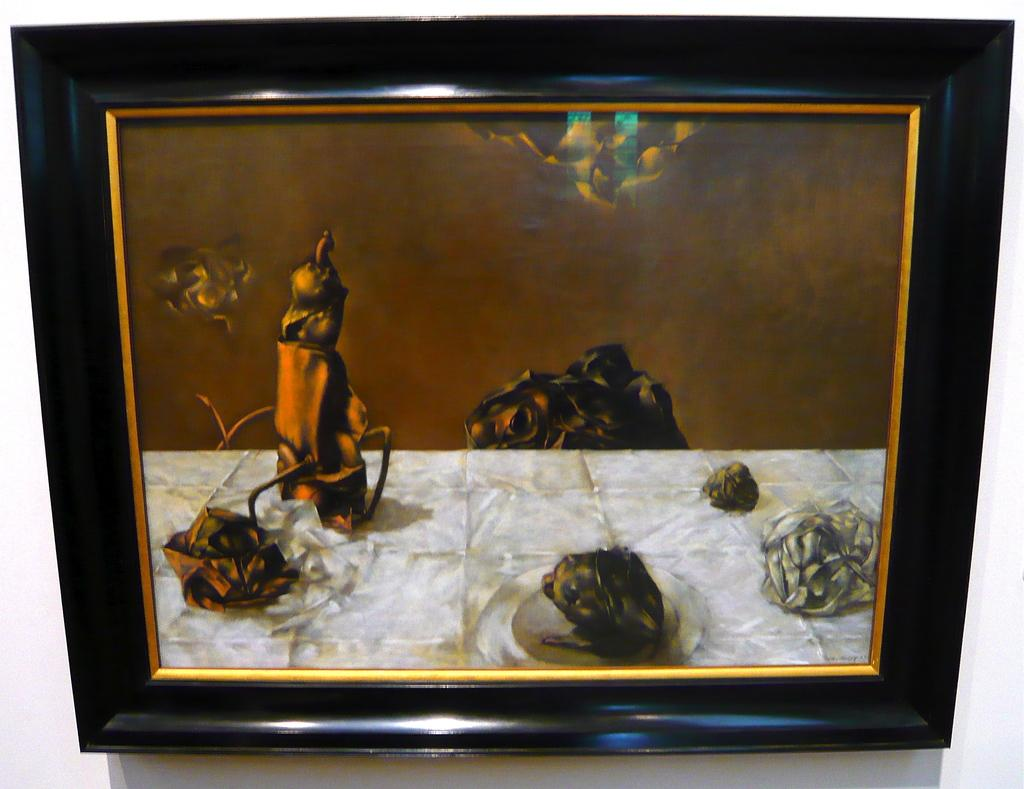What is hanging on the wall in the image? There is a frame hanging on the wall in the image. What type of lead can be seen covering the frame in the image? There is no lead present in the image, nor is there any mention of it being covered. 